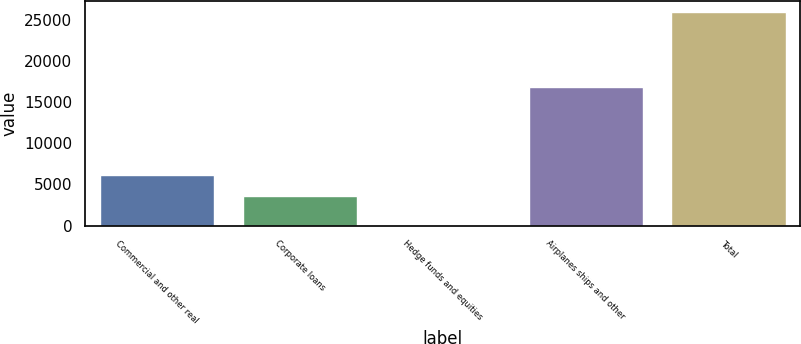<chart> <loc_0><loc_0><loc_500><loc_500><bar_chart><fcel>Commercial and other real<fcel>Corporate loans<fcel>Hedge funds and equities<fcel>Airplanes ships and other<fcel>Total<nl><fcel>6175.1<fcel>3587<fcel>58<fcel>16849<fcel>25939<nl></chart> 